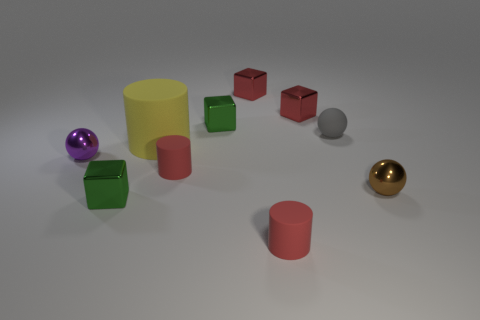There is a small matte object that is behind the yellow thing; what shape is it?
Your answer should be compact. Sphere. What is the size of the matte cylinder that is behind the small metal sphere that is on the left side of the small metallic cube that is in front of the matte sphere?
Your response must be concise. Large. Is the shape of the tiny gray matte object the same as the brown metal thing?
Offer a terse response. Yes. There is a shiny object that is in front of the small purple metallic thing and on the left side of the tiny gray rubber sphere; what is its size?
Offer a very short reply. Small. What is the material of the gray thing that is the same shape as the purple object?
Your response must be concise. Rubber. There is a red cylinder that is to the left of the green metal object behind the brown object; what is its material?
Keep it short and to the point. Rubber. Is the shape of the yellow object the same as the brown thing in front of the tiny purple ball?
Ensure brevity in your answer.  No. What number of rubber objects are large things or large green cylinders?
Make the answer very short. 1. What color is the small metal block that is on the left side of the big rubber thing that is on the right side of the metal ball on the left side of the gray object?
Your response must be concise. Green. How many other things are made of the same material as the small purple sphere?
Keep it short and to the point. 5. 